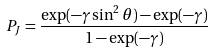<formula> <loc_0><loc_0><loc_500><loc_500>P _ { J } = \frac { \exp ( - \gamma \sin ^ { 2 } \theta ) - \exp ( - \gamma ) } { 1 - \exp ( - \gamma ) }</formula> 